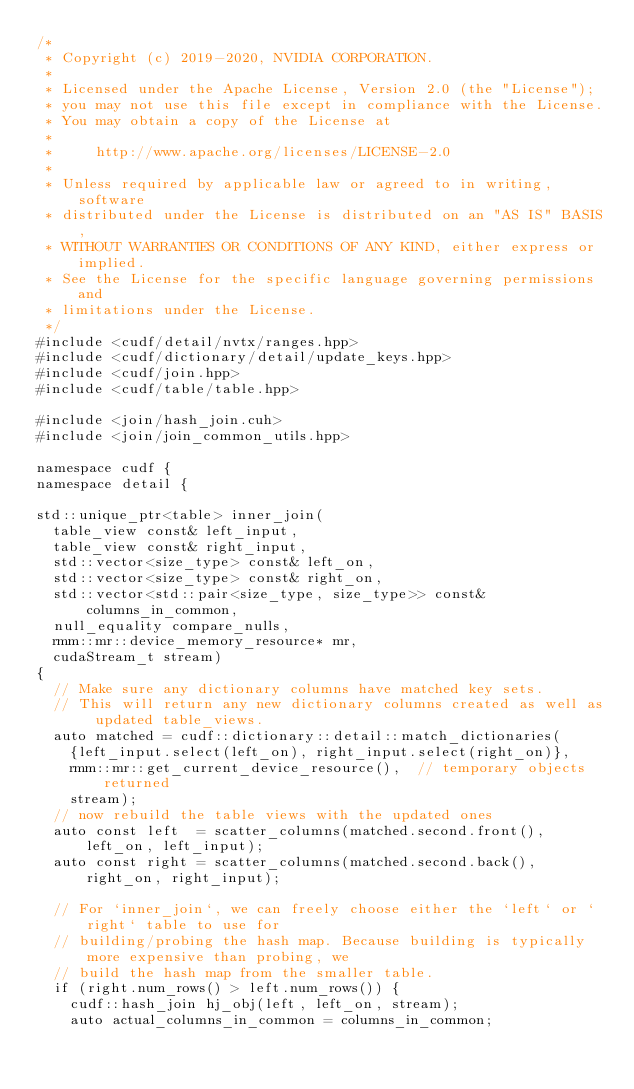Convert code to text. <code><loc_0><loc_0><loc_500><loc_500><_Cuda_>/*
 * Copyright (c) 2019-2020, NVIDIA CORPORATION.
 *
 * Licensed under the Apache License, Version 2.0 (the "License");
 * you may not use this file except in compliance with the License.
 * You may obtain a copy of the License at
 *
 *     http://www.apache.org/licenses/LICENSE-2.0
 *
 * Unless required by applicable law or agreed to in writing, software
 * distributed under the License is distributed on an "AS IS" BASIS,
 * WITHOUT WARRANTIES OR CONDITIONS OF ANY KIND, either express or implied.
 * See the License for the specific language governing permissions and
 * limitations under the License.
 */
#include <cudf/detail/nvtx/ranges.hpp>
#include <cudf/dictionary/detail/update_keys.hpp>
#include <cudf/join.hpp>
#include <cudf/table/table.hpp>

#include <join/hash_join.cuh>
#include <join/join_common_utils.hpp>

namespace cudf {
namespace detail {

std::unique_ptr<table> inner_join(
  table_view const& left_input,
  table_view const& right_input,
  std::vector<size_type> const& left_on,
  std::vector<size_type> const& right_on,
  std::vector<std::pair<size_type, size_type>> const& columns_in_common,
  null_equality compare_nulls,
  rmm::mr::device_memory_resource* mr,
  cudaStream_t stream)
{
  // Make sure any dictionary columns have matched key sets.
  // This will return any new dictionary columns created as well as updated table_views.
  auto matched = cudf::dictionary::detail::match_dictionaries(
    {left_input.select(left_on), right_input.select(right_on)},
    rmm::mr::get_current_device_resource(),  // temporary objects returned
    stream);
  // now rebuild the table views with the updated ones
  auto const left  = scatter_columns(matched.second.front(), left_on, left_input);
  auto const right = scatter_columns(matched.second.back(), right_on, right_input);

  // For `inner_join`, we can freely choose either the `left` or `right` table to use for
  // building/probing the hash map. Because building is typically more expensive than probing, we
  // build the hash map from the smaller table.
  if (right.num_rows() > left.num_rows()) {
    cudf::hash_join hj_obj(left, left_on, stream);
    auto actual_columns_in_common = columns_in_common;</code> 